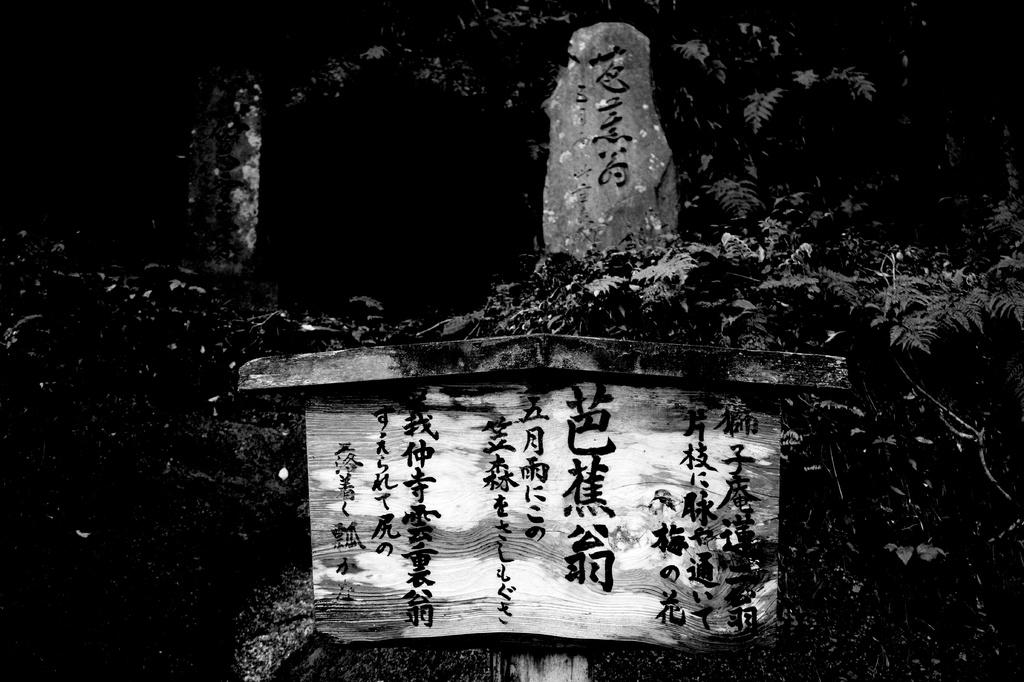What is located in the foreground of the image? There is a house and trees in the foreground of the image. Can you describe the time of day when the image was taken? The image was taken during nighttime. How many babies are sitting at the desk in the image? There is no desk or babies present in the image. 